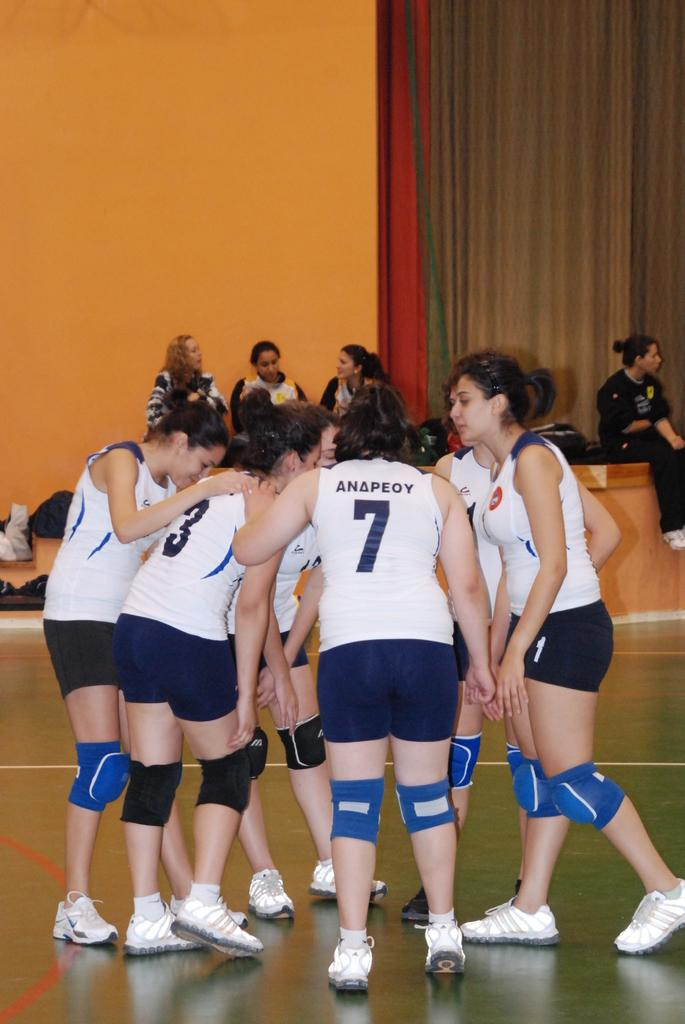<image>
Present a compact description of the photo's key features. A huddle of girls stand in the gymnasium wearing jerseys and knee pads and one player has the name ANAPEO SEVEN on the back. 